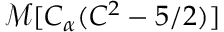Convert formula to latex. <formula><loc_0><loc_0><loc_500><loc_500>\mathcal { M } [ C _ { \alpha } ( C ^ { 2 } - 5 / 2 ) ]</formula> 